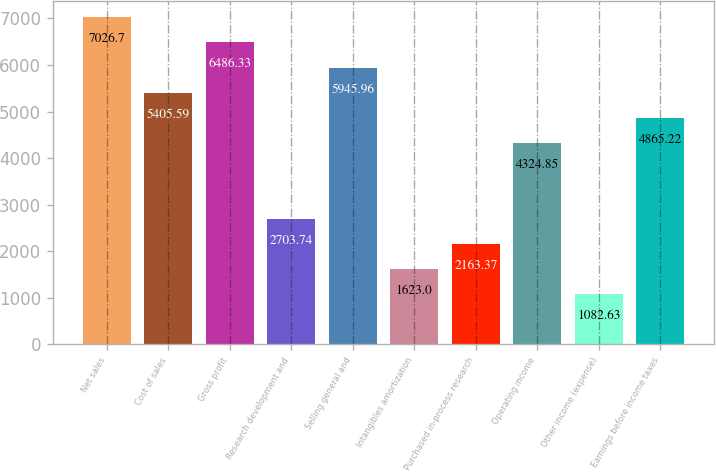<chart> <loc_0><loc_0><loc_500><loc_500><bar_chart><fcel>Net sales<fcel>Cost of sales<fcel>Gross profit<fcel>Research development and<fcel>Selling general and<fcel>Intangibles amortization<fcel>Purchased in-process research<fcel>Operating income<fcel>Other income (expense)<fcel>Earnings before income taxes<nl><fcel>7026.7<fcel>5405.59<fcel>6486.33<fcel>2703.74<fcel>5945.96<fcel>1623<fcel>2163.37<fcel>4324.85<fcel>1082.63<fcel>4865.22<nl></chart> 